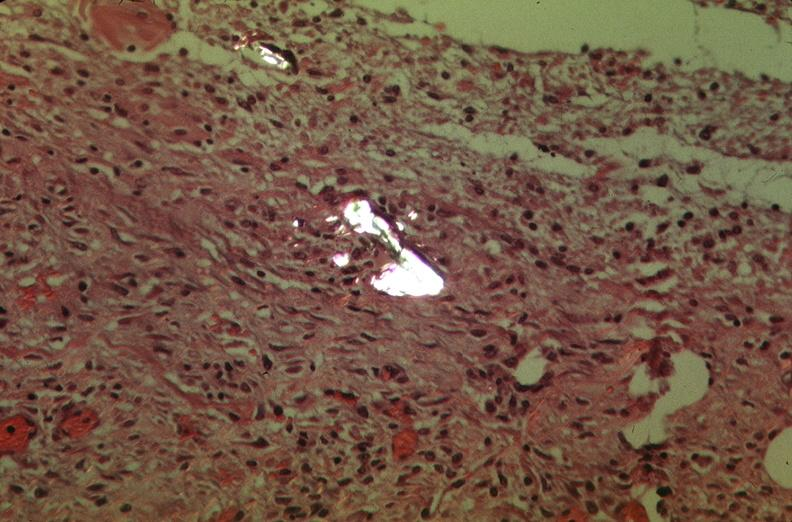how many antitrypsin was talc used to sclerose emphysematous lung, alpha-deficiency?
Answer the question using a single word or phrase. 1 